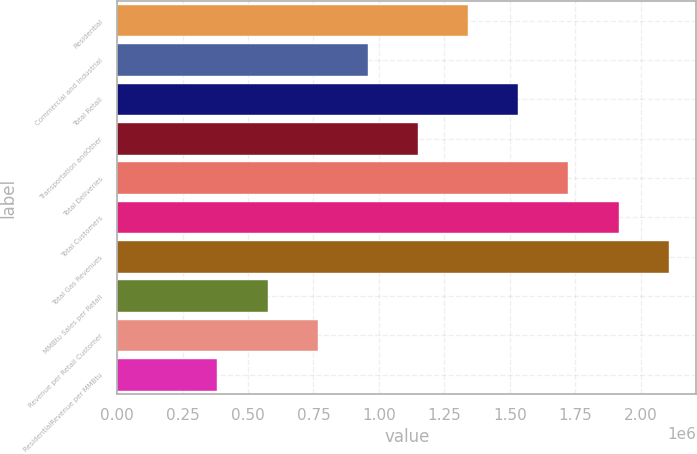Convert chart to OTSL. <chart><loc_0><loc_0><loc_500><loc_500><bar_chart><fcel>Residential<fcel>Commercial and Industrial<fcel>Total Retail<fcel>Transportation andOther<fcel>Total Deliveries<fcel>Total Customers<fcel>Total Gas Revenues<fcel>MMBtu Sales per Retail<fcel>Revenue per Retail Customer<fcel>ResidentialRevenue per MMBtu<nl><fcel>1.34086e+06<fcel>957757<fcel>1.53241e+06<fcel>1.14931e+06<fcel>1.72396e+06<fcel>1.91551e+06<fcel>2.10707e+06<fcel>574655<fcel>766206<fcel>383103<nl></chart> 